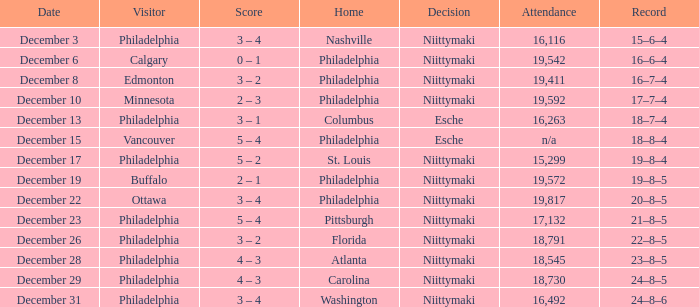What was the score when the attendance was 18,545? 4 – 3. 